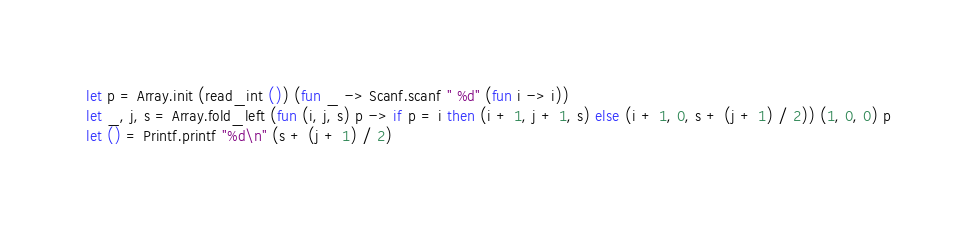<code> <loc_0><loc_0><loc_500><loc_500><_OCaml_>let p = Array.init (read_int ()) (fun _ -> Scanf.scanf " %d" (fun i -> i))
let _, j, s = Array.fold_left (fun (i, j, s) p -> if p = i then (i + 1, j + 1, s) else (i + 1, 0, s + (j + 1) / 2)) (1, 0, 0) p
let () = Printf.printf "%d\n" (s + (j + 1) / 2)
</code> 